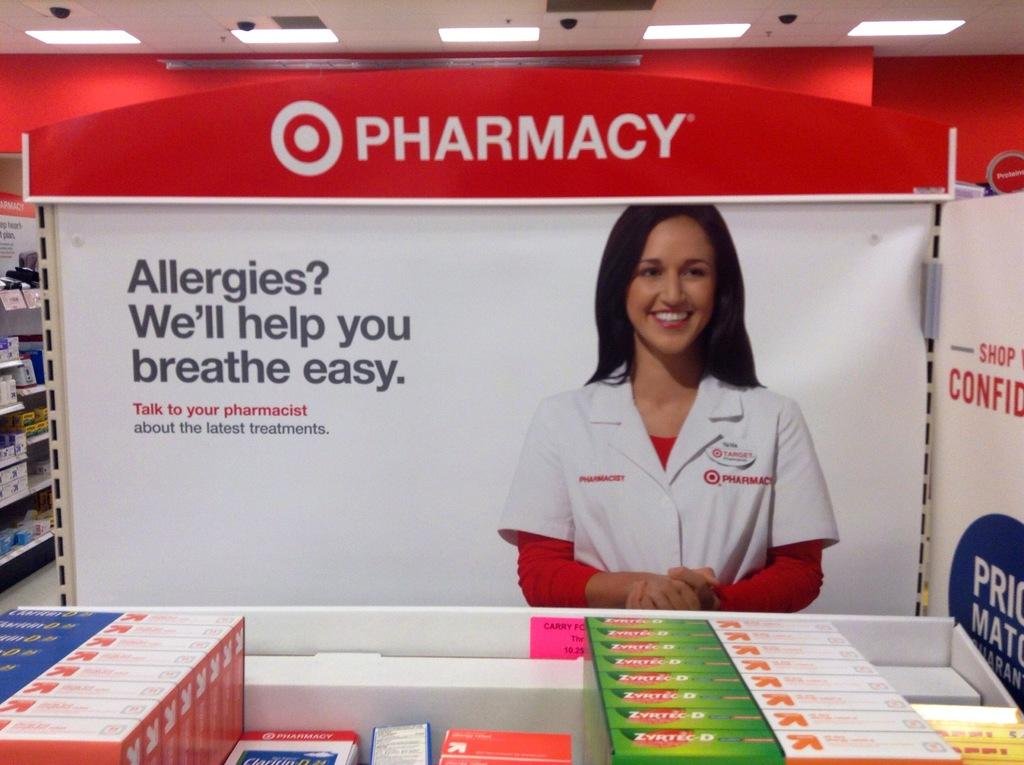<image>
Offer a succinct explanation of the picture presented. A sign for a pharmacy shows a woman in a white coat. 